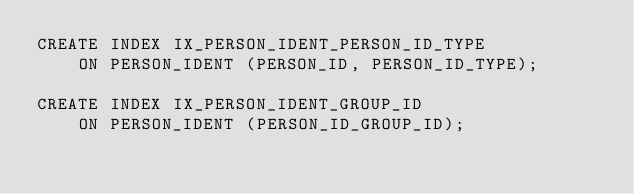Convert code to text. <code><loc_0><loc_0><loc_500><loc_500><_SQL_>CREATE INDEX IX_PERSON_IDENT_PERSON_ID_TYPE
    ON PERSON_IDENT (PERSON_ID, PERSON_ID_TYPE);

CREATE INDEX IX_PERSON_IDENT_GROUP_ID
    ON PERSON_IDENT (PERSON_ID_GROUP_ID);</code> 